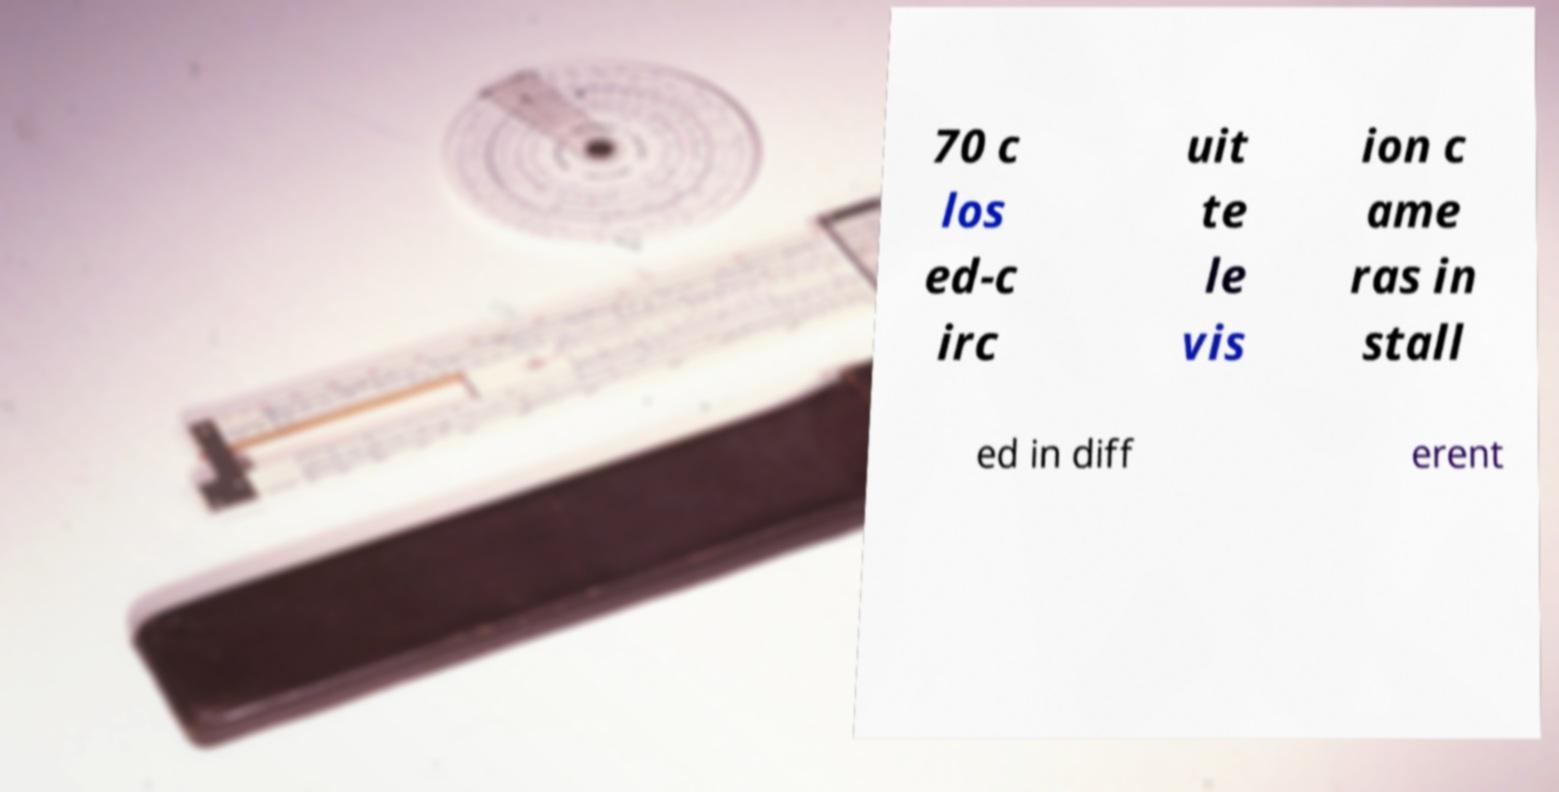Can you accurately transcribe the text from the provided image for me? 70 c los ed-c irc uit te le vis ion c ame ras in stall ed in diff erent 